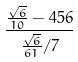<formula> <loc_0><loc_0><loc_500><loc_500>\frac { \frac { \sqrt { 6 } } { 1 0 } - 4 5 6 } { \frac { \sqrt { 6 } } { 6 1 } / 7 }</formula> 